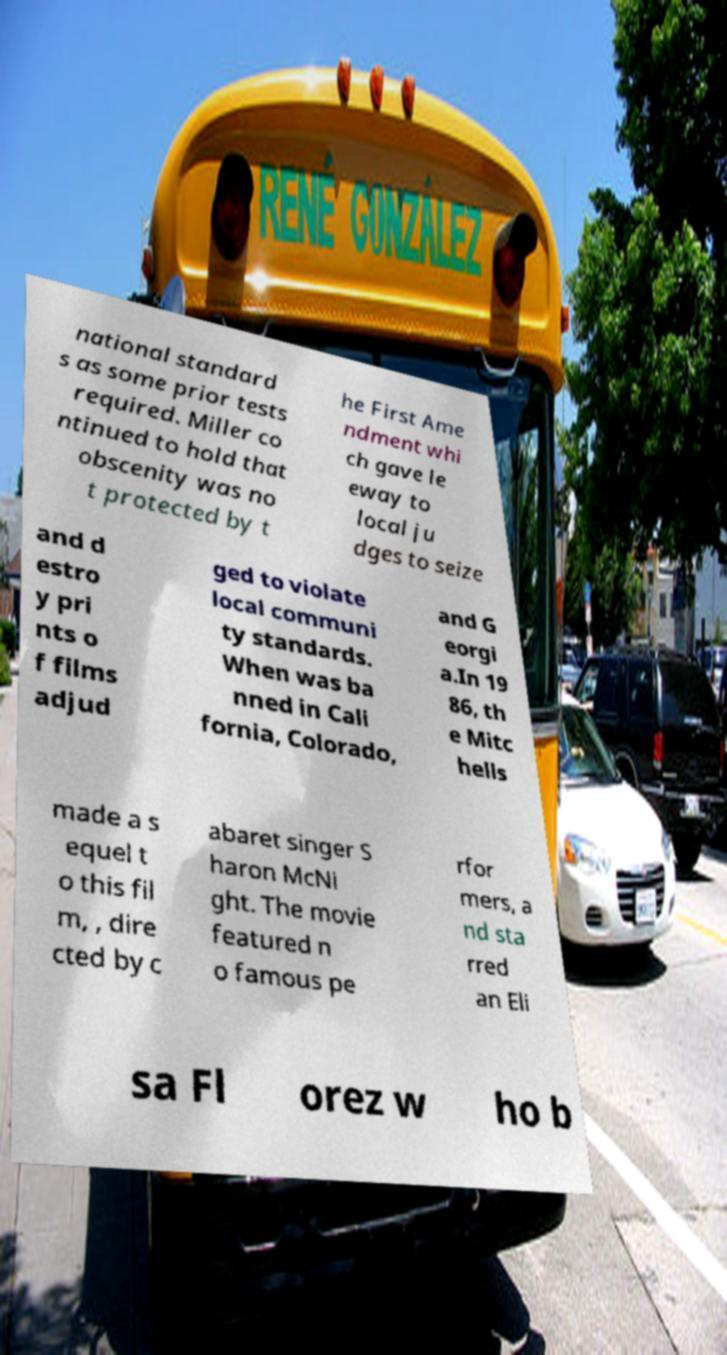I need the written content from this picture converted into text. Can you do that? national standard s as some prior tests required. Miller co ntinued to hold that obscenity was no t protected by t he First Ame ndment whi ch gave le eway to local ju dges to seize and d estro y pri nts o f films adjud ged to violate local communi ty standards. When was ba nned in Cali fornia, Colorado, and G eorgi a.In 19 86, th e Mitc hells made a s equel t o this fil m, , dire cted by c abaret singer S haron McNi ght. The movie featured n o famous pe rfor mers, a nd sta rred an Eli sa Fl orez w ho b 